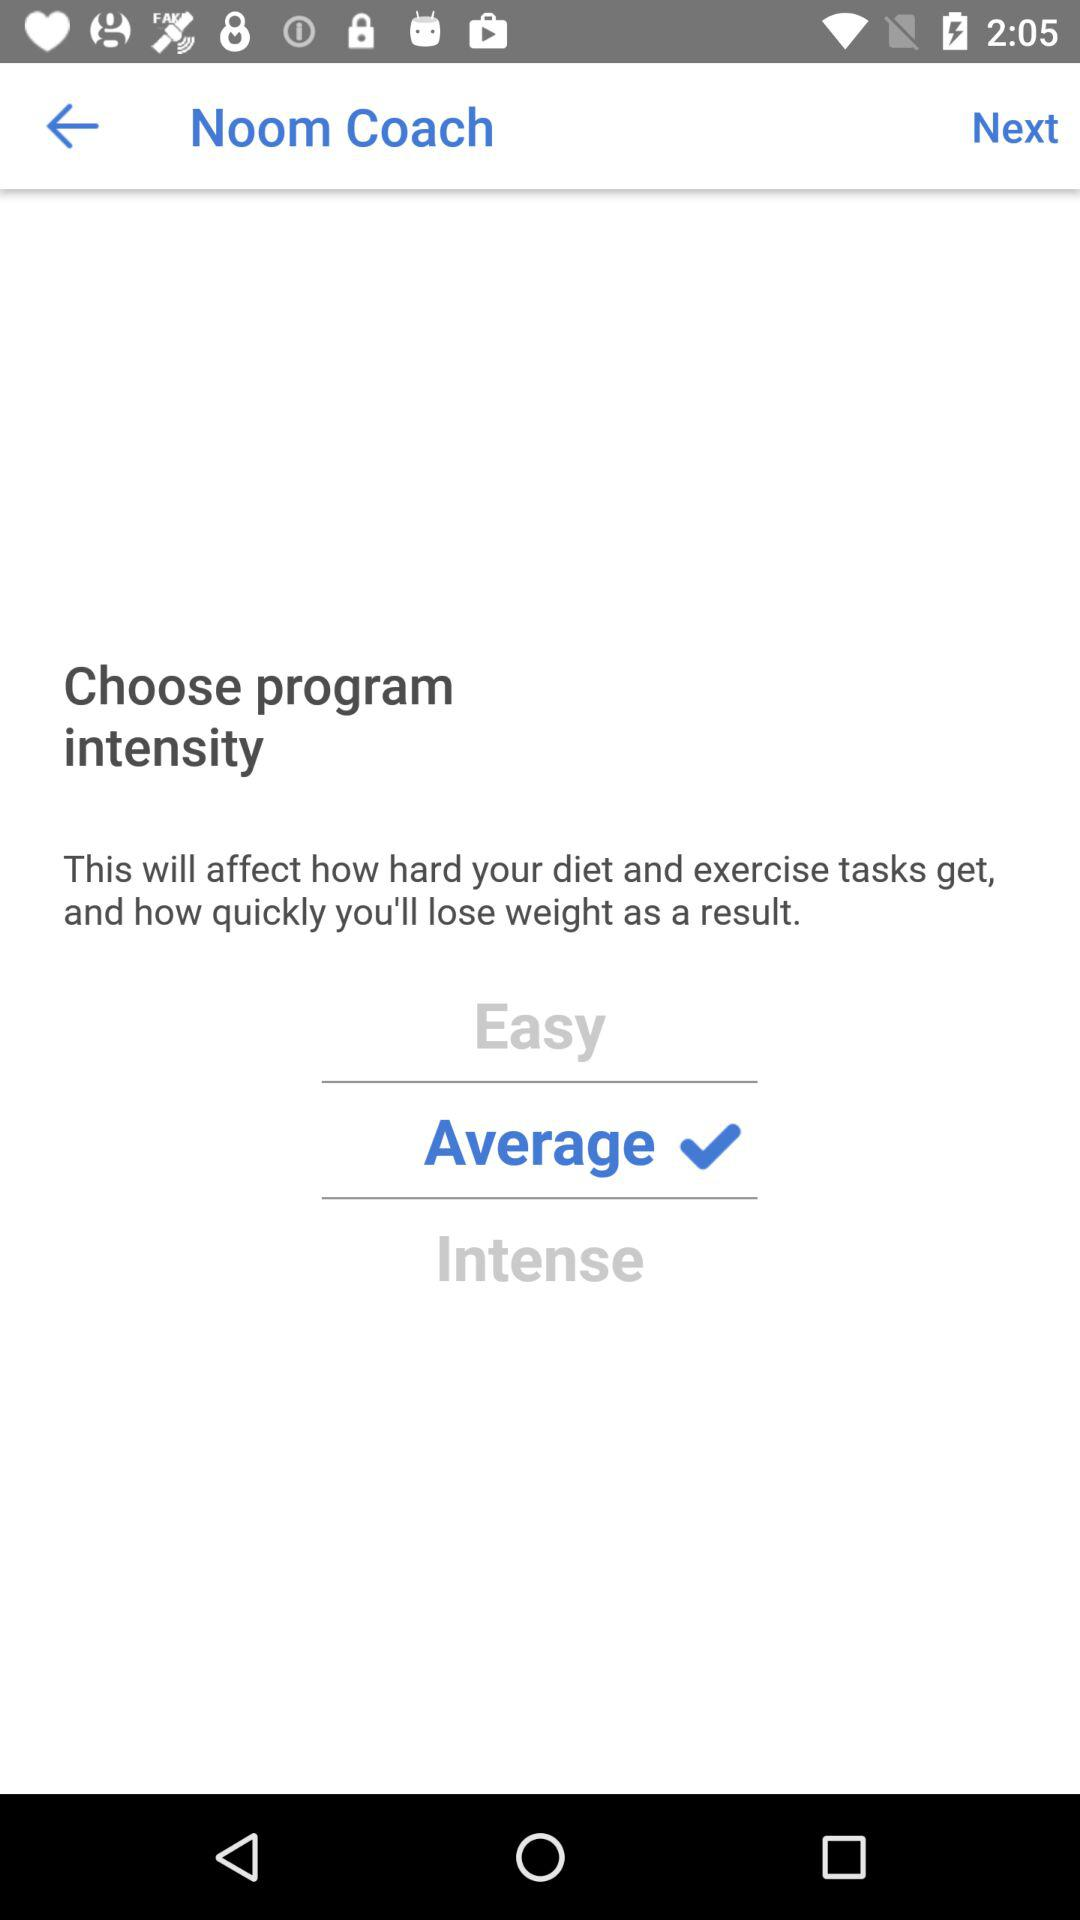Which type of program intensity is selected? The selected type of program intensity is "Average". 